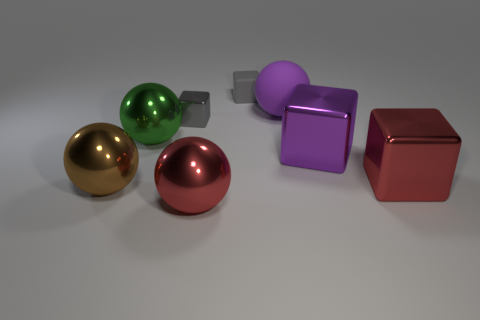Is the number of large brown balls less than the number of big brown metal cylinders?
Give a very brief answer. No. There is a tiny object that is in front of the sphere behind the tiny gray shiny thing; what is its color?
Offer a terse response. Gray. There is a tiny gray object left of the red metal object in front of the big thing that is right of the purple metallic thing; what is it made of?
Provide a short and direct response. Metal. Does the red shiny thing right of the purple sphere have the same size as the large purple block?
Provide a short and direct response. Yes. What is the red thing that is left of the gray rubber block made of?
Your response must be concise. Metal. Is the number of big purple matte balls greater than the number of big spheres?
Your answer should be very brief. No. How many objects are big cubes behind the large red cube or large cyan rubber spheres?
Make the answer very short. 1. How many large red things are in front of the metal sphere behind the big brown metallic thing?
Provide a succinct answer. 2. What is the size of the red shiny object that is behind the big red metal thing that is in front of the big ball that is to the left of the large green metal sphere?
Your answer should be very brief. Large. Do the tiny object that is behind the purple matte ball and the tiny metallic thing have the same color?
Keep it short and to the point. Yes. 